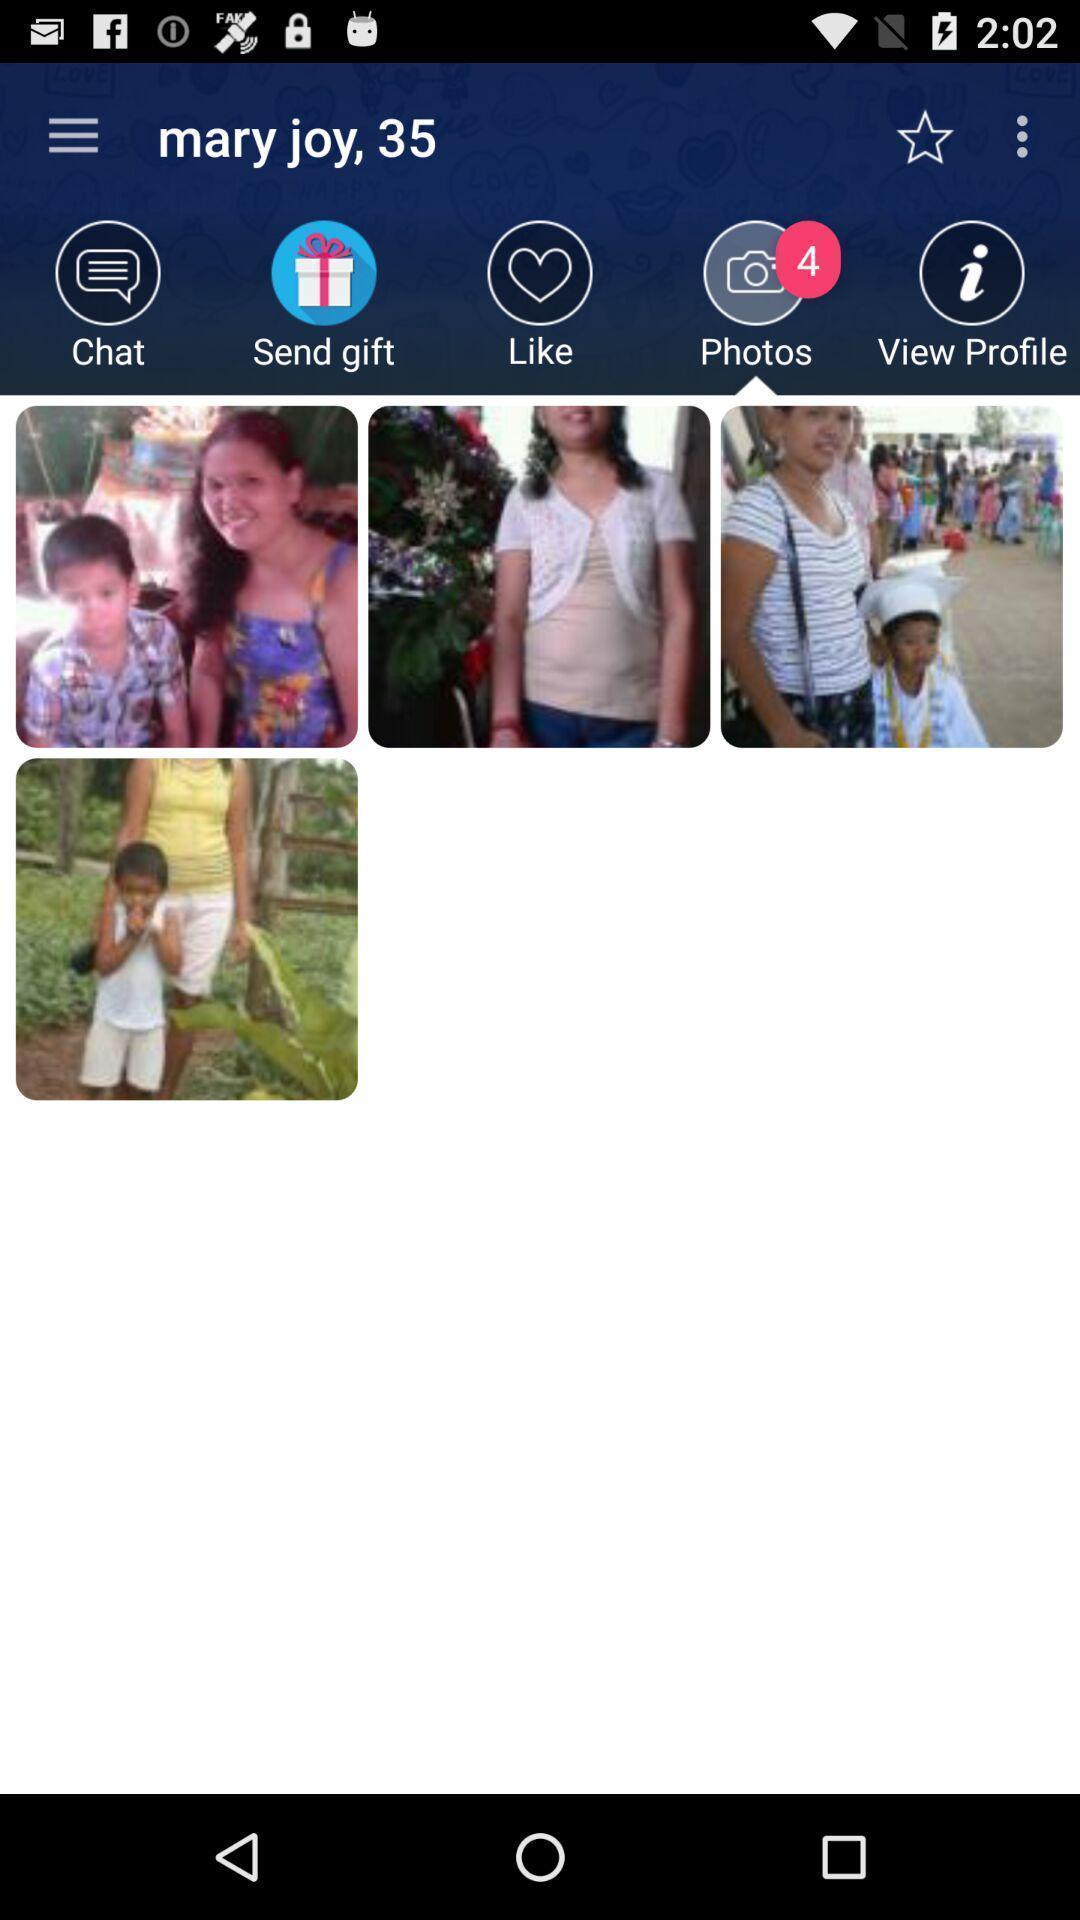Give me a summary of this screen capture. Various images displayed of a profile. 